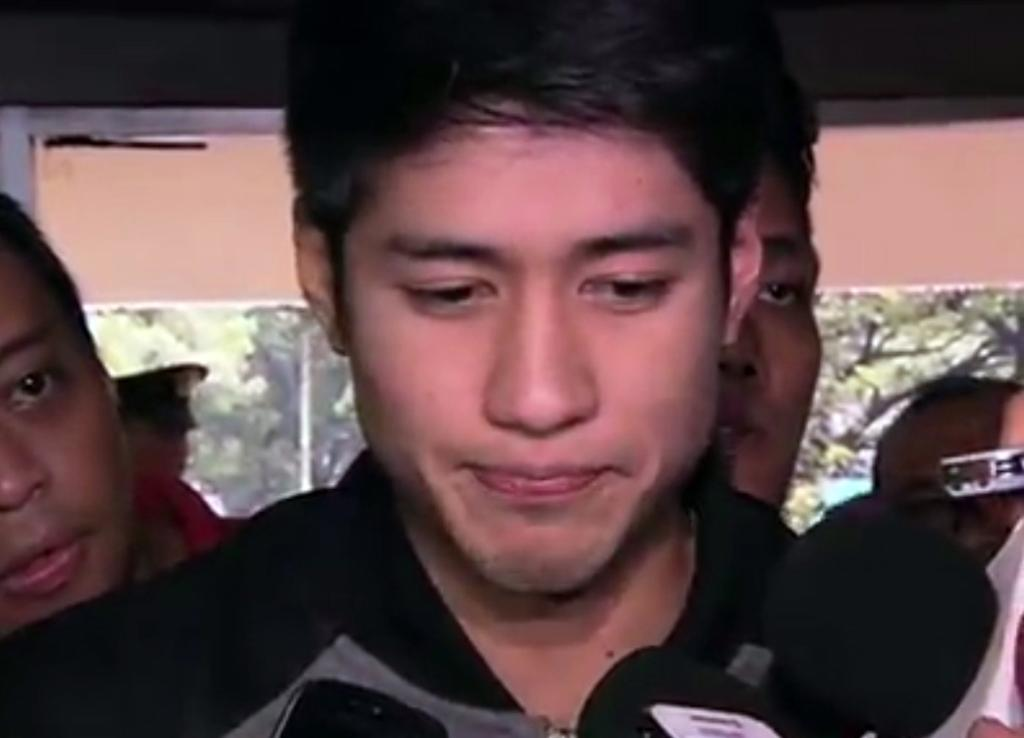What is the main subject of the image? There is a man in the image. What is the man wearing? The man is wearing a black shirt. What can be seen in the background of the image? There is a group of people and trees in the background of the image. What type of sleet can be seen falling in the image? There is no sleet present in the image; it is not raining or snowing. Can you tell me how many kittens are sitting on the man's lap in the image? There are no kittens present in the image; the man is alone in the image. 